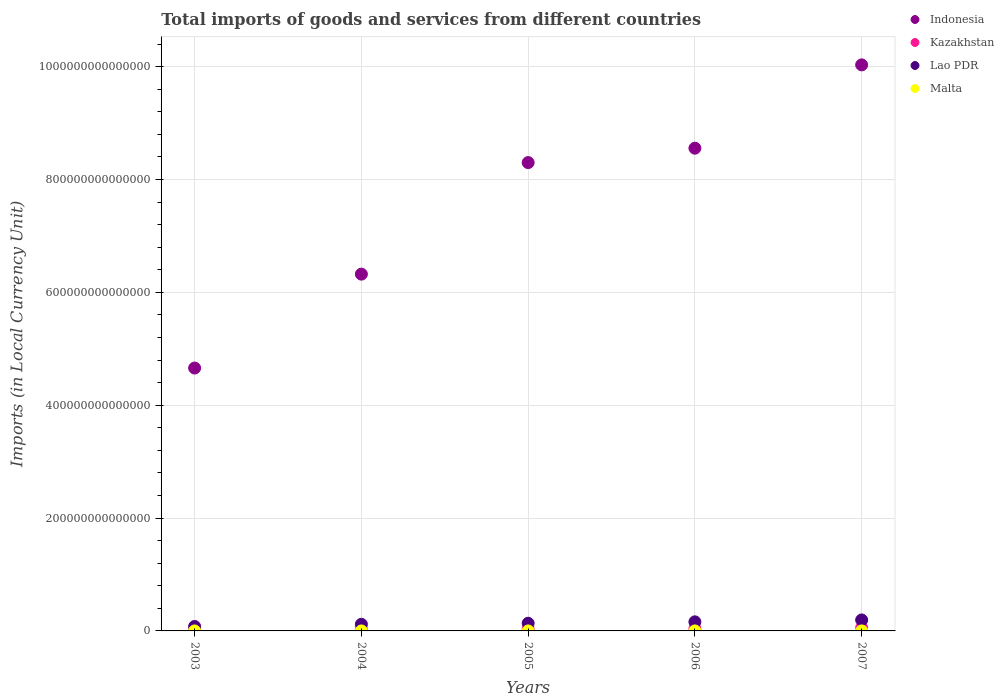What is the Amount of goods and services imports in Malta in 2003?
Give a very brief answer. 3.53e+09. Across all years, what is the maximum Amount of goods and services imports in Malta?
Provide a succinct answer. 5.00e+09. Across all years, what is the minimum Amount of goods and services imports in Malta?
Your response must be concise. 3.53e+09. In which year was the Amount of goods and services imports in Lao PDR minimum?
Provide a short and direct response. 2003. What is the total Amount of goods and services imports in Lao PDR in the graph?
Provide a succinct answer. 6.88e+13. What is the difference between the Amount of goods and services imports in Kazakhstan in 2005 and that in 2006?
Provide a succinct answer. -7.51e+11. What is the difference between the Amount of goods and services imports in Indonesia in 2006 and the Amount of goods and services imports in Lao PDR in 2004?
Ensure brevity in your answer.  8.44e+14. What is the average Amount of goods and services imports in Malta per year?
Provide a short and direct response. 4.13e+09. In the year 2005, what is the difference between the Amount of goods and services imports in Kazakhstan and Amount of goods and services imports in Indonesia?
Keep it short and to the point. -8.27e+14. What is the ratio of the Amount of goods and services imports in Malta in 2005 to that in 2006?
Provide a succinct answer. 0.83. Is the Amount of goods and services imports in Indonesia in 2006 less than that in 2007?
Ensure brevity in your answer.  Yes. What is the difference between the highest and the second highest Amount of goods and services imports in Indonesia?
Provide a succinct answer. 1.48e+14. What is the difference between the highest and the lowest Amount of goods and services imports in Kazakhstan?
Provide a short and direct response. 3.52e+12. Is the sum of the Amount of goods and services imports in Lao PDR in 2005 and 2007 greater than the maximum Amount of goods and services imports in Kazakhstan across all years?
Make the answer very short. Yes. What is the difference between two consecutive major ticks on the Y-axis?
Give a very brief answer. 2.00e+14. Does the graph contain grids?
Keep it short and to the point. Yes. Where does the legend appear in the graph?
Give a very brief answer. Top right. How many legend labels are there?
Provide a short and direct response. 4. What is the title of the graph?
Your answer should be compact. Total imports of goods and services from different countries. What is the label or title of the Y-axis?
Your response must be concise. Imports (in Local Currency Unit). What is the Imports (in Local Currency Unit) of Indonesia in 2003?
Ensure brevity in your answer.  4.66e+14. What is the Imports (in Local Currency Unit) in Kazakhstan in 2003?
Offer a very short reply. 1.99e+12. What is the Imports (in Local Currency Unit) in Lao PDR in 2003?
Ensure brevity in your answer.  7.88e+12. What is the Imports (in Local Currency Unit) in Malta in 2003?
Your answer should be very brief. 3.53e+09. What is the Imports (in Local Currency Unit) in Indonesia in 2004?
Provide a short and direct response. 6.32e+14. What is the Imports (in Local Currency Unit) of Kazakhstan in 2004?
Ensure brevity in your answer.  2.58e+12. What is the Imports (in Local Currency Unit) of Lao PDR in 2004?
Keep it short and to the point. 1.18e+13. What is the Imports (in Local Currency Unit) in Malta in 2004?
Keep it short and to the point. 3.65e+09. What is the Imports (in Local Currency Unit) of Indonesia in 2005?
Keep it short and to the point. 8.30e+14. What is the Imports (in Local Currency Unit) in Kazakhstan in 2005?
Provide a succinct answer. 3.38e+12. What is the Imports (in Local Currency Unit) in Lao PDR in 2005?
Give a very brief answer. 1.36e+13. What is the Imports (in Local Currency Unit) in Malta in 2005?
Provide a short and direct response. 3.85e+09. What is the Imports (in Local Currency Unit) in Indonesia in 2006?
Your answer should be very brief. 8.56e+14. What is the Imports (in Local Currency Unit) of Kazakhstan in 2006?
Provide a succinct answer. 4.13e+12. What is the Imports (in Local Currency Unit) in Lao PDR in 2006?
Your answer should be compact. 1.61e+13. What is the Imports (in Local Currency Unit) in Malta in 2006?
Offer a very short reply. 4.62e+09. What is the Imports (in Local Currency Unit) in Indonesia in 2007?
Your answer should be compact. 1.00e+15. What is the Imports (in Local Currency Unit) of Kazakhstan in 2007?
Keep it short and to the point. 5.51e+12. What is the Imports (in Local Currency Unit) of Lao PDR in 2007?
Provide a short and direct response. 1.94e+13. What is the Imports (in Local Currency Unit) in Malta in 2007?
Your answer should be very brief. 5.00e+09. Across all years, what is the maximum Imports (in Local Currency Unit) in Indonesia?
Offer a terse response. 1.00e+15. Across all years, what is the maximum Imports (in Local Currency Unit) of Kazakhstan?
Your answer should be very brief. 5.51e+12. Across all years, what is the maximum Imports (in Local Currency Unit) of Lao PDR?
Offer a very short reply. 1.94e+13. Across all years, what is the maximum Imports (in Local Currency Unit) in Malta?
Make the answer very short. 5.00e+09. Across all years, what is the minimum Imports (in Local Currency Unit) in Indonesia?
Ensure brevity in your answer.  4.66e+14. Across all years, what is the minimum Imports (in Local Currency Unit) in Kazakhstan?
Keep it short and to the point. 1.99e+12. Across all years, what is the minimum Imports (in Local Currency Unit) in Lao PDR?
Provide a succinct answer. 7.88e+12. Across all years, what is the minimum Imports (in Local Currency Unit) of Malta?
Your answer should be very brief. 3.53e+09. What is the total Imports (in Local Currency Unit) in Indonesia in the graph?
Make the answer very short. 3.79e+15. What is the total Imports (in Local Currency Unit) of Kazakhstan in the graph?
Keep it short and to the point. 1.76e+13. What is the total Imports (in Local Currency Unit) in Lao PDR in the graph?
Offer a terse response. 6.88e+13. What is the total Imports (in Local Currency Unit) in Malta in the graph?
Ensure brevity in your answer.  2.06e+1. What is the difference between the Imports (in Local Currency Unit) in Indonesia in 2003 and that in 2004?
Your response must be concise. -1.66e+14. What is the difference between the Imports (in Local Currency Unit) in Kazakhstan in 2003 and that in 2004?
Offer a terse response. -5.92e+11. What is the difference between the Imports (in Local Currency Unit) of Lao PDR in 2003 and that in 2004?
Make the answer very short. -3.88e+12. What is the difference between the Imports (in Local Currency Unit) in Malta in 2003 and that in 2004?
Your answer should be very brief. -1.19e+08. What is the difference between the Imports (in Local Currency Unit) in Indonesia in 2003 and that in 2005?
Your answer should be compact. -3.64e+14. What is the difference between the Imports (in Local Currency Unit) of Kazakhstan in 2003 and that in 2005?
Your response must be concise. -1.40e+12. What is the difference between the Imports (in Local Currency Unit) in Lao PDR in 2003 and that in 2005?
Provide a short and direct response. -5.67e+12. What is the difference between the Imports (in Local Currency Unit) in Malta in 2003 and that in 2005?
Give a very brief answer. -3.16e+08. What is the difference between the Imports (in Local Currency Unit) in Indonesia in 2003 and that in 2006?
Give a very brief answer. -3.90e+14. What is the difference between the Imports (in Local Currency Unit) of Kazakhstan in 2003 and that in 2006?
Provide a succinct answer. -2.15e+12. What is the difference between the Imports (in Local Currency Unit) in Lao PDR in 2003 and that in 2006?
Offer a very short reply. -8.23e+12. What is the difference between the Imports (in Local Currency Unit) of Malta in 2003 and that in 2006?
Offer a terse response. -1.09e+09. What is the difference between the Imports (in Local Currency Unit) of Indonesia in 2003 and that in 2007?
Your response must be concise. -5.37e+14. What is the difference between the Imports (in Local Currency Unit) in Kazakhstan in 2003 and that in 2007?
Ensure brevity in your answer.  -3.52e+12. What is the difference between the Imports (in Local Currency Unit) of Lao PDR in 2003 and that in 2007?
Keep it short and to the point. -1.16e+13. What is the difference between the Imports (in Local Currency Unit) of Malta in 2003 and that in 2007?
Provide a succinct answer. -1.46e+09. What is the difference between the Imports (in Local Currency Unit) of Indonesia in 2004 and that in 2005?
Provide a succinct answer. -1.98e+14. What is the difference between the Imports (in Local Currency Unit) of Kazakhstan in 2004 and that in 2005?
Keep it short and to the point. -8.05e+11. What is the difference between the Imports (in Local Currency Unit) in Lao PDR in 2004 and that in 2005?
Provide a short and direct response. -1.79e+12. What is the difference between the Imports (in Local Currency Unit) in Malta in 2004 and that in 2005?
Offer a terse response. -1.97e+08. What is the difference between the Imports (in Local Currency Unit) of Indonesia in 2004 and that in 2006?
Your answer should be compact. -2.23e+14. What is the difference between the Imports (in Local Currency Unit) of Kazakhstan in 2004 and that in 2006?
Make the answer very short. -1.56e+12. What is the difference between the Imports (in Local Currency Unit) in Lao PDR in 2004 and that in 2006?
Give a very brief answer. -4.35e+12. What is the difference between the Imports (in Local Currency Unit) of Malta in 2004 and that in 2006?
Offer a very short reply. -9.67e+08. What is the difference between the Imports (in Local Currency Unit) of Indonesia in 2004 and that in 2007?
Ensure brevity in your answer.  -3.71e+14. What is the difference between the Imports (in Local Currency Unit) of Kazakhstan in 2004 and that in 2007?
Your answer should be compact. -2.93e+12. What is the difference between the Imports (in Local Currency Unit) of Lao PDR in 2004 and that in 2007?
Provide a succinct answer. -7.69e+12. What is the difference between the Imports (in Local Currency Unit) in Malta in 2004 and that in 2007?
Give a very brief answer. -1.34e+09. What is the difference between the Imports (in Local Currency Unit) in Indonesia in 2005 and that in 2006?
Provide a short and direct response. -2.55e+13. What is the difference between the Imports (in Local Currency Unit) of Kazakhstan in 2005 and that in 2006?
Provide a short and direct response. -7.51e+11. What is the difference between the Imports (in Local Currency Unit) of Lao PDR in 2005 and that in 2006?
Your response must be concise. -2.56e+12. What is the difference between the Imports (in Local Currency Unit) of Malta in 2005 and that in 2006?
Your answer should be very brief. -7.69e+08. What is the difference between the Imports (in Local Currency Unit) in Indonesia in 2005 and that in 2007?
Provide a short and direct response. -1.73e+14. What is the difference between the Imports (in Local Currency Unit) in Kazakhstan in 2005 and that in 2007?
Provide a succinct answer. -2.12e+12. What is the difference between the Imports (in Local Currency Unit) in Lao PDR in 2005 and that in 2007?
Make the answer very short. -5.90e+12. What is the difference between the Imports (in Local Currency Unit) in Malta in 2005 and that in 2007?
Ensure brevity in your answer.  -1.15e+09. What is the difference between the Imports (in Local Currency Unit) in Indonesia in 2006 and that in 2007?
Make the answer very short. -1.48e+14. What is the difference between the Imports (in Local Currency Unit) in Kazakhstan in 2006 and that in 2007?
Your answer should be compact. -1.37e+12. What is the difference between the Imports (in Local Currency Unit) in Lao PDR in 2006 and that in 2007?
Make the answer very short. -3.34e+12. What is the difference between the Imports (in Local Currency Unit) in Malta in 2006 and that in 2007?
Your answer should be compact. -3.77e+08. What is the difference between the Imports (in Local Currency Unit) of Indonesia in 2003 and the Imports (in Local Currency Unit) of Kazakhstan in 2004?
Your answer should be compact. 4.63e+14. What is the difference between the Imports (in Local Currency Unit) in Indonesia in 2003 and the Imports (in Local Currency Unit) in Lao PDR in 2004?
Provide a succinct answer. 4.54e+14. What is the difference between the Imports (in Local Currency Unit) in Indonesia in 2003 and the Imports (in Local Currency Unit) in Malta in 2004?
Ensure brevity in your answer.  4.66e+14. What is the difference between the Imports (in Local Currency Unit) of Kazakhstan in 2003 and the Imports (in Local Currency Unit) of Lao PDR in 2004?
Ensure brevity in your answer.  -9.78e+12. What is the difference between the Imports (in Local Currency Unit) in Kazakhstan in 2003 and the Imports (in Local Currency Unit) in Malta in 2004?
Keep it short and to the point. 1.98e+12. What is the difference between the Imports (in Local Currency Unit) in Lao PDR in 2003 and the Imports (in Local Currency Unit) in Malta in 2004?
Provide a succinct answer. 7.88e+12. What is the difference between the Imports (in Local Currency Unit) of Indonesia in 2003 and the Imports (in Local Currency Unit) of Kazakhstan in 2005?
Your answer should be compact. 4.63e+14. What is the difference between the Imports (in Local Currency Unit) of Indonesia in 2003 and the Imports (in Local Currency Unit) of Lao PDR in 2005?
Offer a terse response. 4.52e+14. What is the difference between the Imports (in Local Currency Unit) in Indonesia in 2003 and the Imports (in Local Currency Unit) in Malta in 2005?
Your answer should be compact. 4.66e+14. What is the difference between the Imports (in Local Currency Unit) of Kazakhstan in 2003 and the Imports (in Local Currency Unit) of Lao PDR in 2005?
Your answer should be very brief. -1.16e+13. What is the difference between the Imports (in Local Currency Unit) of Kazakhstan in 2003 and the Imports (in Local Currency Unit) of Malta in 2005?
Your answer should be compact. 1.98e+12. What is the difference between the Imports (in Local Currency Unit) of Lao PDR in 2003 and the Imports (in Local Currency Unit) of Malta in 2005?
Make the answer very short. 7.88e+12. What is the difference between the Imports (in Local Currency Unit) of Indonesia in 2003 and the Imports (in Local Currency Unit) of Kazakhstan in 2006?
Offer a terse response. 4.62e+14. What is the difference between the Imports (in Local Currency Unit) of Indonesia in 2003 and the Imports (in Local Currency Unit) of Lao PDR in 2006?
Provide a short and direct response. 4.50e+14. What is the difference between the Imports (in Local Currency Unit) of Indonesia in 2003 and the Imports (in Local Currency Unit) of Malta in 2006?
Keep it short and to the point. 4.66e+14. What is the difference between the Imports (in Local Currency Unit) in Kazakhstan in 2003 and the Imports (in Local Currency Unit) in Lao PDR in 2006?
Give a very brief answer. -1.41e+13. What is the difference between the Imports (in Local Currency Unit) in Kazakhstan in 2003 and the Imports (in Local Currency Unit) in Malta in 2006?
Provide a succinct answer. 1.98e+12. What is the difference between the Imports (in Local Currency Unit) of Lao PDR in 2003 and the Imports (in Local Currency Unit) of Malta in 2006?
Your answer should be very brief. 7.88e+12. What is the difference between the Imports (in Local Currency Unit) of Indonesia in 2003 and the Imports (in Local Currency Unit) of Kazakhstan in 2007?
Offer a very short reply. 4.60e+14. What is the difference between the Imports (in Local Currency Unit) of Indonesia in 2003 and the Imports (in Local Currency Unit) of Lao PDR in 2007?
Provide a succinct answer. 4.46e+14. What is the difference between the Imports (in Local Currency Unit) of Indonesia in 2003 and the Imports (in Local Currency Unit) of Malta in 2007?
Give a very brief answer. 4.66e+14. What is the difference between the Imports (in Local Currency Unit) of Kazakhstan in 2003 and the Imports (in Local Currency Unit) of Lao PDR in 2007?
Provide a succinct answer. -1.75e+13. What is the difference between the Imports (in Local Currency Unit) of Kazakhstan in 2003 and the Imports (in Local Currency Unit) of Malta in 2007?
Offer a terse response. 1.98e+12. What is the difference between the Imports (in Local Currency Unit) in Lao PDR in 2003 and the Imports (in Local Currency Unit) in Malta in 2007?
Offer a terse response. 7.88e+12. What is the difference between the Imports (in Local Currency Unit) of Indonesia in 2004 and the Imports (in Local Currency Unit) of Kazakhstan in 2005?
Offer a very short reply. 6.29e+14. What is the difference between the Imports (in Local Currency Unit) of Indonesia in 2004 and the Imports (in Local Currency Unit) of Lao PDR in 2005?
Keep it short and to the point. 6.19e+14. What is the difference between the Imports (in Local Currency Unit) of Indonesia in 2004 and the Imports (in Local Currency Unit) of Malta in 2005?
Give a very brief answer. 6.32e+14. What is the difference between the Imports (in Local Currency Unit) in Kazakhstan in 2004 and the Imports (in Local Currency Unit) in Lao PDR in 2005?
Keep it short and to the point. -1.10e+13. What is the difference between the Imports (in Local Currency Unit) in Kazakhstan in 2004 and the Imports (in Local Currency Unit) in Malta in 2005?
Ensure brevity in your answer.  2.57e+12. What is the difference between the Imports (in Local Currency Unit) of Lao PDR in 2004 and the Imports (in Local Currency Unit) of Malta in 2005?
Ensure brevity in your answer.  1.18e+13. What is the difference between the Imports (in Local Currency Unit) in Indonesia in 2004 and the Imports (in Local Currency Unit) in Kazakhstan in 2006?
Your answer should be very brief. 6.28e+14. What is the difference between the Imports (in Local Currency Unit) of Indonesia in 2004 and the Imports (in Local Currency Unit) of Lao PDR in 2006?
Ensure brevity in your answer.  6.16e+14. What is the difference between the Imports (in Local Currency Unit) in Indonesia in 2004 and the Imports (in Local Currency Unit) in Malta in 2006?
Your response must be concise. 6.32e+14. What is the difference between the Imports (in Local Currency Unit) in Kazakhstan in 2004 and the Imports (in Local Currency Unit) in Lao PDR in 2006?
Give a very brief answer. -1.35e+13. What is the difference between the Imports (in Local Currency Unit) in Kazakhstan in 2004 and the Imports (in Local Currency Unit) in Malta in 2006?
Offer a terse response. 2.57e+12. What is the difference between the Imports (in Local Currency Unit) of Lao PDR in 2004 and the Imports (in Local Currency Unit) of Malta in 2006?
Keep it short and to the point. 1.18e+13. What is the difference between the Imports (in Local Currency Unit) of Indonesia in 2004 and the Imports (in Local Currency Unit) of Kazakhstan in 2007?
Provide a short and direct response. 6.27e+14. What is the difference between the Imports (in Local Currency Unit) of Indonesia in 2004 and the Imports (in Local Currency Unit) of Lao PDR in 2007?
Give a very brief answer. 6.13e+14. What is the difference between the Imports (in Local Currency Unit) in Indonesia in 2004 and the Imports (in Local Currency Unit) in Malta in 2007?
Offer a very short reply. 6.32e+14. What is the difference between the Imports (in Local Currency Unit) in Kazakhstan in 2004 and the Imports (in Local Currency Unit) in Lao PDR in 2007?
Your answer should be compact. -1.69e+13. What is the difference between the Imports (in Local Currency Unit) of Kazakhstan in 2004 and the Imports (in Local Currency Unit) of Malta in 2007?
Provide a succinct answer. 2.57e+12. What is the difference between the Imports (in Local Currency Unit) in Lao PDR in 2004 and the Imports (in Local Currency Unit) in Malta in 2007?
Keep it short and to the point. 1.18e+13. What is the difference between the Imports (in Local Currency Unit) of Indonesia in 2005 and the Imports (in Local Currency Unit) of Kazakhstan in 2006?
Provide a short and direct response. 8.26e+14. What is the difference between the Imports (in Local Currency Unit) in Indonesia in 2005 and the Imports (in Local Currency Unit) in Lao PDR in 2006?
Ensure brevity in your answer.  8.14e+14. What is the difference between the Imports (in Local Currency Unit) of Indonesia in 2005 and the Imports (in Local Currency Unit) of Malta in 2006?
Make the answer very short. 8.30e+14. What is the difference between the Imports (in Local Currency Unit) of Kazakhstan in 2005 and the Imports (in Local Currency Unit) of Lao PDR in 2006?
Give a very brief answer. -1.27e+13. What is the difference between the Imports (in Local Currency Unit) in Kazakhstan in 2005 and the Imports (in Local Currency Unit) in Malta in 2006?
Give a very brief answer. 3.38e+12. What is the difference between the Imports (in Local Currency Unit) of Lao PDR in 2005 and the Imports (in Local Currency Unit) of Malta in 2006?
Your answer should be very brief. 1.35e+13. What is the difference between the Imports (in Local Currency Unit) in Indonesia in 2005 and the Imports (in Local Currency Unit) in Kazakhstan in 2007?
Your answer should be very brief. 8.25e+14. What is the difference between the Imports (in Local Currency Unit) of Indonesia in 2005 and the Imports (in Local Currency Unit) of Lao PDR in 2007?
Make the answer very short. 8.11e+14. What is the difference between the Imports (in Local Currency Unit) of Indonesia in 2005 and the Imports (in Local Currency Unit) of Malta in 2007?
Provide a succinct answer. 8.30e+14. What is the difference between the Imports (in Local Currency Unit) of Kazakhstan in 2005 and the Imports (in Local Currency Unit) of Lao PDR in 2007?
Your answer should be compact. -1.61e+13. What is the difference between the Imports (in Local Currency Unit) of Kazakhstan in 2005 and the Imports (in Local Currency Unit) of Malta in 2007?
Your answer should be very brief. 3.38e+12. What is the difference between the Imports (in Local Currency Unit) in Lao PDR in 2005 and the Imports (in Local Currency Unit) in Malta in 2007?
Your response must be concise. 1.35e+13. What is the difference between the Imports (in Local Currency Unit) of Indonesia in 2006 and the Imports (in Local Currency Unit) of Kazakhstan in 2007?
Your response must be concise. 8.50e+14. What is the difference between the Imports (in Local Currency Unit) of Indonesia in 2006 and the Imports (in Local Currency Unit) of Lao PDR in 2007?
Provide a succinct answer. 8.36e+14. What is the difference between the Imports (in Local Currency Unit) of Indonesia in 2006 and the Imports (in Local Currency Unit) of Malta in 2007?
Offer a very short reply. 8.56e+14. What is the difference between the Imports (in Local Currency Unit) of Kazakhstan in 2006 and the Imports (in Local Currency Unit) of Lao PDR in 2007?
Give a very brief answer. -1.53e+13. What is the difference between the Imports (in Local Currency Unit) of Kazakhstan in 2006 and the Imports (in Local Currency Unit) of Malta in 2007?
Make the answer very short. 4.13e+12. What is the difference between the Imports (in Local Currency Unit) in Lao PDR in 2006 and the Imports (in Local Currency Unit) in Malta in 2007?
Ensure brevity in your answer.  1.61e+13. What is the average Imports (in Local Currency Unit) in Indonesia per year?
Offer a terse response. 7.57e+14. What is the average Imports (in Local Currency Unit) of Kazakhstan per year?
Ensure brevity in your answer.  3.52e+12. What is the average Imports (in Local Currency Unit) of Lao PDR per year?
Provide a succinct answer. 1.38e+13. What is the average Imports (in Local Currency Unit) in Malta per year?
Give a very brief answer. 4.13e+09. In the year 2003, what is the difference between the Imports (in Local Currency Unit) in Indonesia and Imports (in Local Currency Unit) in Kazakhstan?
Make the answer very short. 4.64e+14. In the year 2003, what is the difference between the Imports (in Local Currency Unit) of Indonesia and Imports (in Local Currency Unit) of Lao PDR?
Provide a short and direct response. 4.58e+14. In the year 2003, what is the difference between the Imports (in Local Currency Unit) in Indonesia and Imports (in Local Currency Unit) in Malta?
Your response must be concise. 4.66e+14. In the year 2003, what is the difference between the Imports (in Local Currency Unit) of Kazakhstan and Imports (in Local Currency Unit) of Lao PDR?
Your response must be concise. -5.90e+12. In the year 2003, what is the difference between the Imports (in Local Currency Unit) in Kazakhstan and Imports (in Local Currency Unit) in Malta?
Provide a short and direct response. 1.98e+12. In the year 2003, what is the difference between the Imports (in Local Currency Unit) of Lao PDR and Imports (in Local Currency Unit) of Malta?
Give a very brief answer. 7.88e+12. In the year 2004, what is the difference between the Imports (in Local Currency Unit) in Indonesia and Imports (in Local Currency Unit) in Kazakhstan?
Provide a short and direct response. 6.30e+14. In the year 2004, what is the difference between the Imports (in Local Currency Unit) of Indonesia and Imports (in Local Currency Unit) of Lao PDR?
Ensure brevity in your answer.  6.21e+14. In the year 2004, what is the difference between the Imports (in Local Currency Unit) in Indonesia and Imports (in Local Currency Unit) in Malta?
Make the answer very short. 6.32e+14. In the year 2004, what is the difference between the Imports (in Local Currency Unit) of Kazakhstan and Imports (in Local Currency Unit) of Lao PDR?
Keep it short and to the point. -9.18e+12. In the year 2004, what is the difference between the Imports (in Local Currency Unit) of Kazakhstan and Imports (in Local Currency Unit) of Malta?
Your answer should be very brief. 2.57e+12. In the year 2004, what is the difference between the Imports (in Local Currency Unit) of Lao PDR and Imports (in Local Currency Unit) of Malta?
Provide a short and direct response. 1.18e+13. In the year 2005, what is the difference between the Imports (in Local Currency Unit) in Indonesia and Imports (in Local Currency Unit) in Kazakhstan?
Keep it short and to the point. 8.27e+14. In the year 2005, what is the difference between the Imports (in Local Currency Unit) of Indonesia and Imports (in Local Currency Unit) of Lao PDR?
Your answer should be compact. 8.17e+14. In the year 2005, what is the difference between the Imports (in Local Currency Unit) of Indonesia and Imports (in Local Currency Unit) of Malta?
Your response must be concise. 8.30e+14. In the year 2005, what is the difference between the Imports (in Local Currency Unit) of Kazakhstan and Imports (in Local Currency Unit) of Lao PDR?
Offer a very short reply. -1.02e+13. In the year 2005, what is the difference between the Imports (in Local Currency Unit) of Kazakhstan and Imports (in Local Currency Unit) of Malta?
Offer a terse response. 3.38e+12. In the year 2005, what is the difference between the Imports (in Local Currency Unit) of Lao PDR and Imports (in Local Currency Unit) of Malta?
Keep it short and to the point. 1.35e+13. In the year 2006, what is the difference between the Imports (in Local Currency Unit) in Indonesia and Imports (in Local Currency Unit) in Kazakhstan?
Your response must be concise. 8.51e+14. In the year 2006, what is the difference between the Imports (in Local Currency Unit) of Indonesia and Imports (in Local Currency Unit) of Lao PDR?
Provide a succinct answer. 8.39e+14. In the year 2006, what is the difference between the Imports (in Local Currency Unit) in Indonesia and Imports (in Local Currency Unit) in Malta?
Provide a succinct answer. 8.56e+14. In the year 2006, what is the difference between the Imports (in Local Currency Unit) of Kazakhstan and Imports (in Local Currency Unit) of Lao PDR?
Offer a very short reply. -1.20e+13. In the year 2006, what is the difference between the Imports (in Local Currency Unit) in Kazakhstan and Imports (in Local Currency Unit) in Malta?
Provide a short and direct response. 4.13e+12. In the year 2006, what is the difference between the Imports (in Local Currency Unit) in Lao PDR and Imports (in Local Currency Unit) in Malta?
Offer a terse response. 1.61e+13. In the year 2007, what is the difference between the Imports (in Local Currency Unit) of Indonesia and Imports (in Local Currency Unit) of Kazakhstan?
Give a very brief answer. 9.98e+14. In the year 2007, what is the difference between the Imports (in Local Currency Unit) of Indonesia and Imports (in Local Currency Unit) of Lao PDR?
Give a very brief answer. 9.84e+14. In the year 2007, what is the difference between the Imports (in Local Currency Unit) in Indonesia and Imports (in Local Currency Unit) in Malta?
Ensure brevity in your answer.  1.00e+15. In the year 2007, what is the difference between the Imports (in Local Currency Unit) of Kazakhstan and Imports (in Local Currency Unit) of Lao PDR?
Offer a terse response. -1.39e+13. In the year 2007, what is the difference between the Imports (in Local Currency Unit) of Kazakhstan and Imports (in Local Currency Unit) of Malta?
Your answer should be very brief. 5.50e+12. In the year 2007, what is the difference between the Imports (in Local Currency Unit) in Lao PDR and Imports (in Local Currency Unit) in Malta?
Make the answer very short. 1.94e+13. What is the ratio of the Imports (in Local Currency Unit) of Indonesia in 2003 to that in 2004?
Ensure brevity in your answer.  0.74. What is the ratio of the Imports (in Local Currency Unit) of Kazakhstan in 2003 to that in 2004?
Your answer should be compact. 0.77. What is the ratio of the Imports (in Local Currency Unit) in Lao PDR in 2003 to that in 2004?
Ensure brevity in your answer.  0.67. What is the ratio of the Imports (in Local Currency Unit) in Malta in 2003 to that in 2004?
Offer a terse response. 0.97. What is the ratio of the Imports (in Local Currency Unit) in Indonesia in 2003 to that in 2005?
Ensure brevity in your answer.  0.56. What is the ratio of the Imports (in Local Currency Unit) in Kazakhstan in 2003 to that in 2005?
Provide a short and direct response. 0.59. What is the ratio of the Imports (in Local Currency Unit) of Lao PDR in 2003 to that in 2005?
Your answer should be very brief. 0.58. What is the ratio of the Imports (in Local Currency Unit) of Malta in 2003 to that in 2005?
Offer a terse response. 0.92. What is the ratio of the Imports (in Local Currency Unit) of Indonesia in 2003 to that in 2006?
Keep it short and to the point. 0.54. What is the ratio of the Imports (in Local Currency Unit) of Kazakhstan in 2003 to that in 2006?
Offer a very short reply. 0.48. What is the ratio of the Imports (in Local Currency Unit) in Lao PDR in 2003 to that in 2006?
Offer a very short reply. 0.49. What is the ratio of the Imports (in Local Currency Unit) of Malta in 2003 to that in 2006?
Give a very brief answer. 0.77. What is the ratio of the Imports (in Local Currency Unit) of Indonesia in 2003 to that in 2007?
Your response must be concise. 0.46. What is the ratio of the Imports (in Local Currency Unit) of Kazakhstan in 2003 to that in 2007?
Ensure brevity in your answer.  0.36. What is the ratio of the Imports (in Local Currency Unit) of Lao PDR in 2003 to that in 2007?
Keep it short and to the point. 0.41. What is the ratio of the Imports (in Local Currency Unit) in Malta in 2003 to that in 2007?
Your answer should be compact. 0.71. What is the ratio of the Imports (in Local Currency Unit) in Indonesia in 2004 to that in 2005?
Your answer should be compact. 0.76. What is the ratio of the Imports (in Local Currency Unit) of Kazakhstan in 2004 to that in 2005?
Give a very brief answer. 0.76. What is the ratio of the Imports (in Local Currency Unit) of Lao PDR in 2004 to that in 2005?
Offer a terse response. 0.87. What is the ratio of the Imports (in Local Currency Unit) in Malta in 2004 to that in 2005?
Provide a succinct answer. 0.95. What is the ratio of the Imports (in Local Currency Unit) in Indonesia in 2004 to that in 2006?
Your answer should be compact. 0.74. What is the ratio of the Imports (in Local Currency Unit) in Kazakhstan in 2004 to that in 2006?
Your answer should be very brief. 0.62. What is the ratio of the Imports (in Local Currency Unit) in Lao PDR in 2004 to that in 2006?
Offer a terse response. 0.73. What is the ratio of the Imports (in Local Currency Unit) of Malta in 2004 to that in 2006?
Your answer should be compact. 0.79. What is the ratio of the Imports (in Local Currency Unit) of Indonesia in 2004 to that in 2007?
Provide a short and direct response. 0.63. What is the ratio of the Imports (in Local Currency Unit) of Kazakhstan in 2004 to that in 2007?
Ensure brevity in your answer.  0.47. What is the ratio of the Imports (in Local Currency Unit) in Lao PDR in 2004 to that in 2007?
Offer a terse response. 0.6. What is the ratio of the Imports (in Local Currency Unit) of Malta in 2004 to that in 2007?
Give a very brief answer. 0.73. What is the ratio of the Imports (in Local Currency Unit) of Indonesia in 2005 to that in 2006?
Ensure brevity in your answer.  0.97. What is the ratio of the Imports (in Local Currency Unit) in Kazakhstan in 2005 to that in 2006?
Keep it short and to the point. 0.82. What is the ratio of the Imports (in Local Currency Unit) in Lao PDR in 2005 to that in 2006?
Your answer should be compact. 0.84. What is the ratio of the Imports (in Local Currency Unit) in Malta in 2005 to that in 2006?
Your answer should be compact. 0.83. What is the ratio of the Imports (in Local Currency Unit) of Indonesia in 2005 to that in 2007?
Your response must be concise. 0.83. What is the ratio of the Imports (in Local Currency Unit) of Kazakhstan in 2005 to that in 2007?
Offer a terse response. 0.61. What is the ratio of the Imports (in Local Currency Unit) of Lao PDR in 2005 to that in 2007?
Ensure brevity in your answer.  0.7. What is the ratio of the Imports (in Local Currency Unit) in Malta in 2005 to that in 2007?
Your answer should be very brief. 0.77. What is the ratio of the Imports (in Local Currency Unit) in Indonesia in 2006 to that in 2007?
Your answer should be very brief. 0.85. What is the ratio of the Imports (in Local Currency Unit) of Kazakhstan in 2006 to that in 2007?
Offer a terse response. 0.75. What is the ratio of the Imports (in Local Currency Unit) of Lao PDR in 2006 to that in 2007?
Your answer should be very brief. 0.83. What is the ratio of the Imports (in Local Currency Unit) in Malta in 2006 to that in 2007?
Keep it short and to the point. 0.92. What is the difference between the highest and the second highest Imports (in Local Currency Unit) in Indonesia?
Give a very brief answer. 1.48e+14. What is the difference between the highest and the second highest Imports (in Local Currency Unit) of Kazakhstan?
Offer a very short reply. 1.37e+12. What is the difference between the highest and the second highest Imports (in Local Currency Unit) in Lao PDR?
Your answer should be compact. 3.34e+12. What is the difference between the highest and the second highest Imports (in Local Currency Unit) in Malta?
Your answer should be compact. 3.77e+08. What is the difference between the highest and the lowest Imports (in Local Currency Unit) in Indonesia?
Your response must be concise. 5.37e+14. What is the difference between the highest and the lowest Imports (in Local Currency Unit) of Kazakhstan?
Offer a very short reply. 3.52e+12. What is the difference between the highest and the lowest Imports (in Local Currency Unit) of Lao PDR?
Keep it short and to the point. 1.16e+13. What is the difference between the highest and the lowest Imports (in Local Currency Unit) of Malta?
Offer a very short reply. 1.46e+09. 